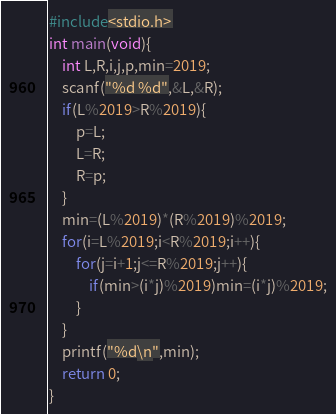Convert code to text. <code><loc_0><loc_0><loc_500><loc_500><_C_>#include<stdio.h>
int main(void){
    int L,R,i,j,p,min=2019;
    scanf("%d %d",&L,&R);
    if(L%2019>R%2019){
        p=L;
        L=R;
        R=p;
    }
    min=(L%2019)*(R%2019)%2019;
    for(i=L%2019;i<R%2019;i++){
        for(j=i+1;j<=R%2019;j++){
            if(min>(i*j)%2019)min=(i*j)%2019;
        }
    }
    printf("%d\n",min);
    return 0;
}</code> 